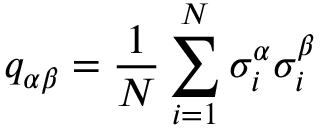<formula> <loc_0><loc_0><loc_500><loc_500>{ { q } _ { \alpha \beta } } = \frac { 1 } { N } \sum _ { i = 1 } ^ { N } { \sigma _ { i } ^ { \alpha } } \sigma _ { i } ^ { \beta }</formula> 